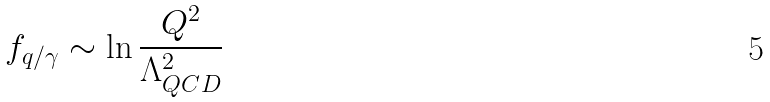Convert formula to latex. <formula><loc_0><loc_0><loc_500><loc_500>f _ { q / \gamma } \sim \ln { \frac { Q ^ { 2 } } { \Lambda _ { Q C D } ^ { 2 } } }</formula> 